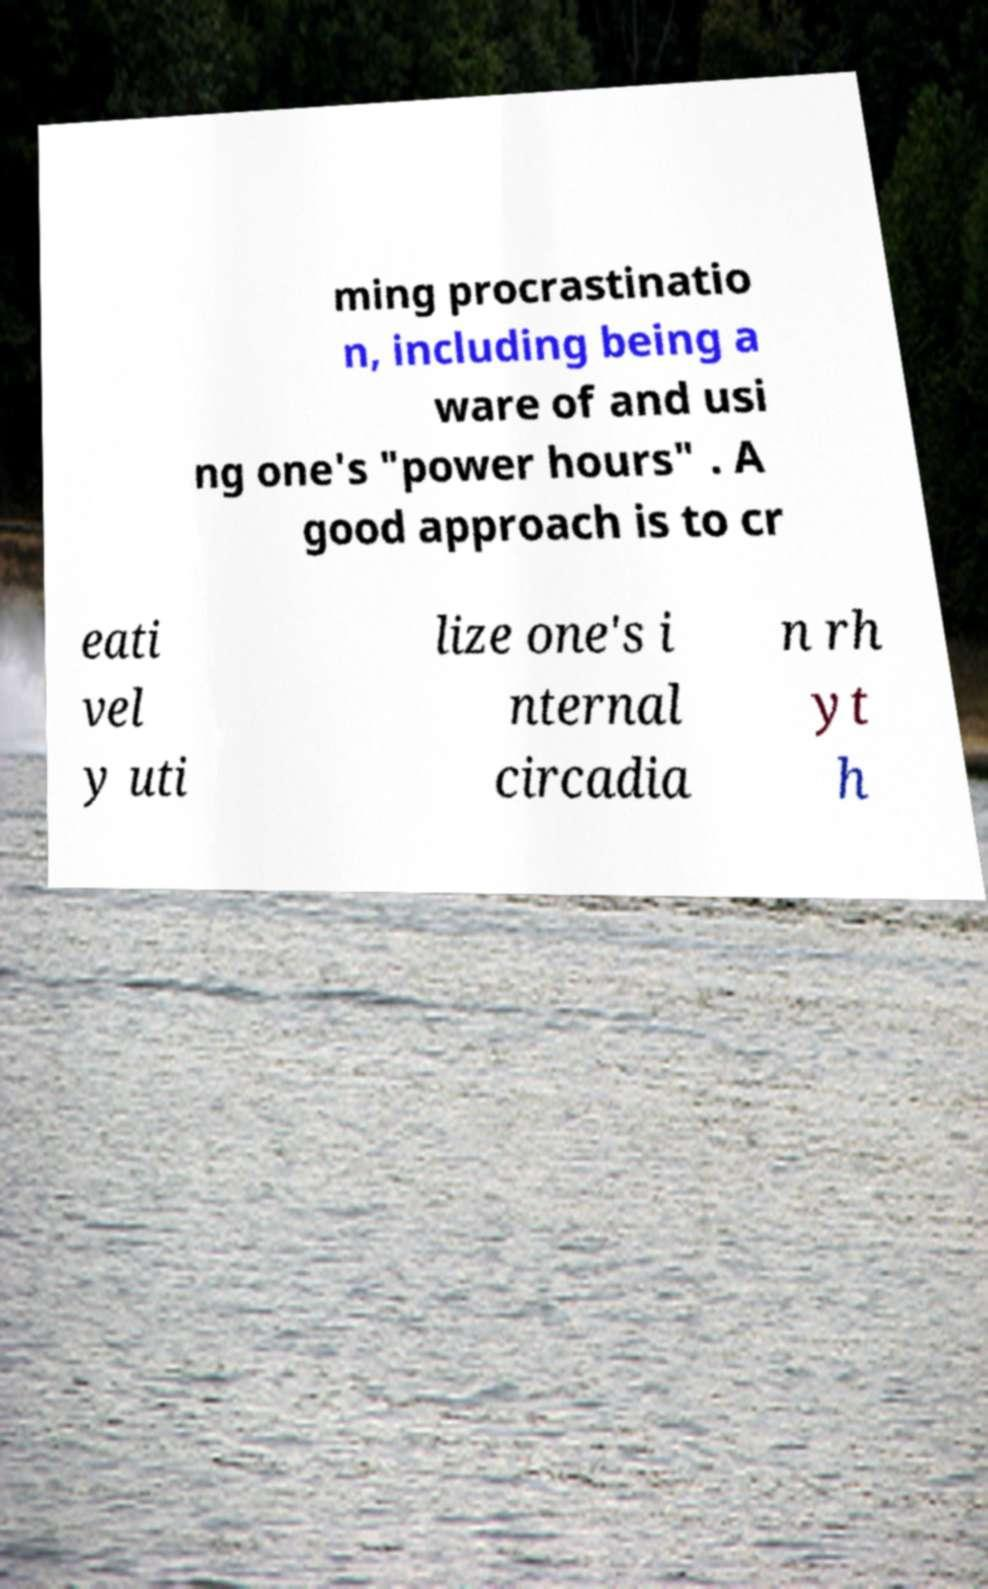Please read and relay the text visible in this image. What does it say? ming procrastinatio n, including being a ware of and usi ng one's "power hours" . A good approach is to cr eati vel y uti lize one's i nternal circadia n rh yt h 